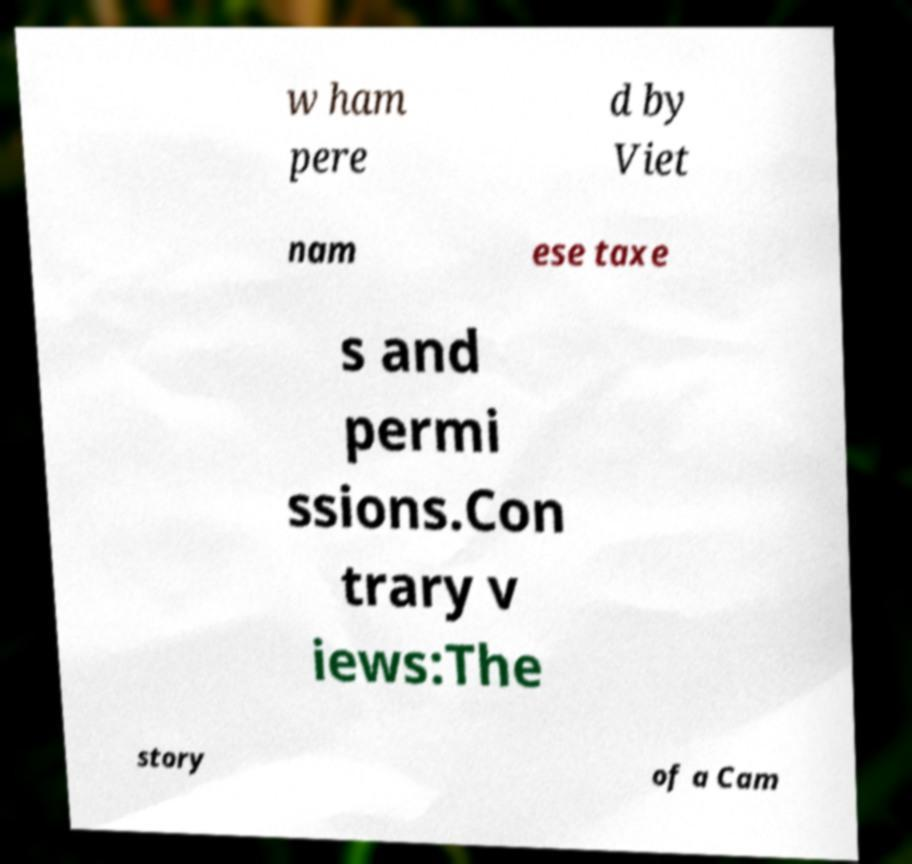Could you assist in decoding the text presented in this image and type it out clearly? w ham pere d by Viet nam ese taxe s and permi ssions.Con trary v iews:The story of a Cam 